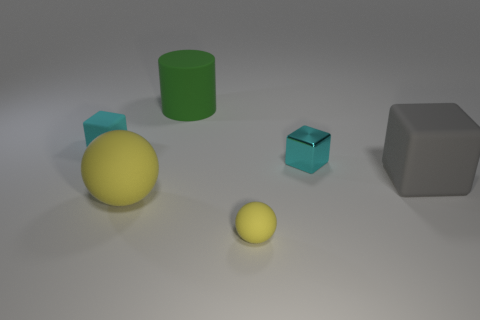What is the color of the small sphere?
Give a very brief answer. Yellow. Does the small rubber object behind the tiny cyan metallic cube have the same shape as the big yellow rubber thing?
Ensure brevity in your answer.  No. What material is the big yellow ball?
Offer a terse response. Rubber. There is a yellow matte thing that is the same size as the cyan matte cube; what is its shape?
Ensure brevity in your answer.  Sphere. Are there any tiny matte balls that have the same color as the tiny metallic block?
Give a very brief answer. No. There is a large matte cylinder; is it the same color as the matte cube to the left of the green object?
Your answer should be very brief. No. What color is the rubber cube in front of the matte block that is behind the gray thing?
Your response must be concise. Gray. Are there any blocks that are in front of the cyan block on the right side of the yellow rubber thing on the right side of the cylinder?
Keep it short and to the point. Yes. What is the color of the cube that is the same material as the big gray thing?
Provide a short and direct response. Cyan. What number of small blocks are the same material as the big gray cube?
Keep it short and to the point. 1. 